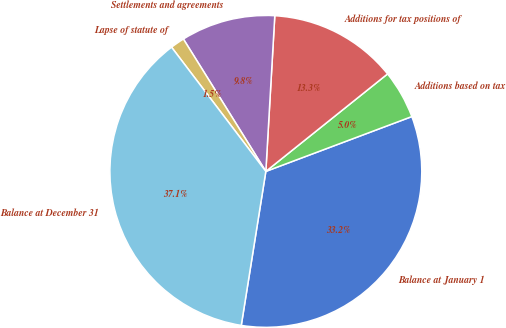Convert chart to OTSL. <chart><loc_0><loc_0><loc_500><loc_500><pie_chart><fcel>Balance at January 1<fcel>Additions based on tax<fcel>Additions for tax positions of<fcel>Settlements and agreements<fcel>Lapse of statute of<fcel>Balance at December 31<nl><fcel>33.24%<fcel>5.03%<fcel>13.34%<fcel>9.78%<fcel>1.47%<fcel>37.15%<nl></chart> 